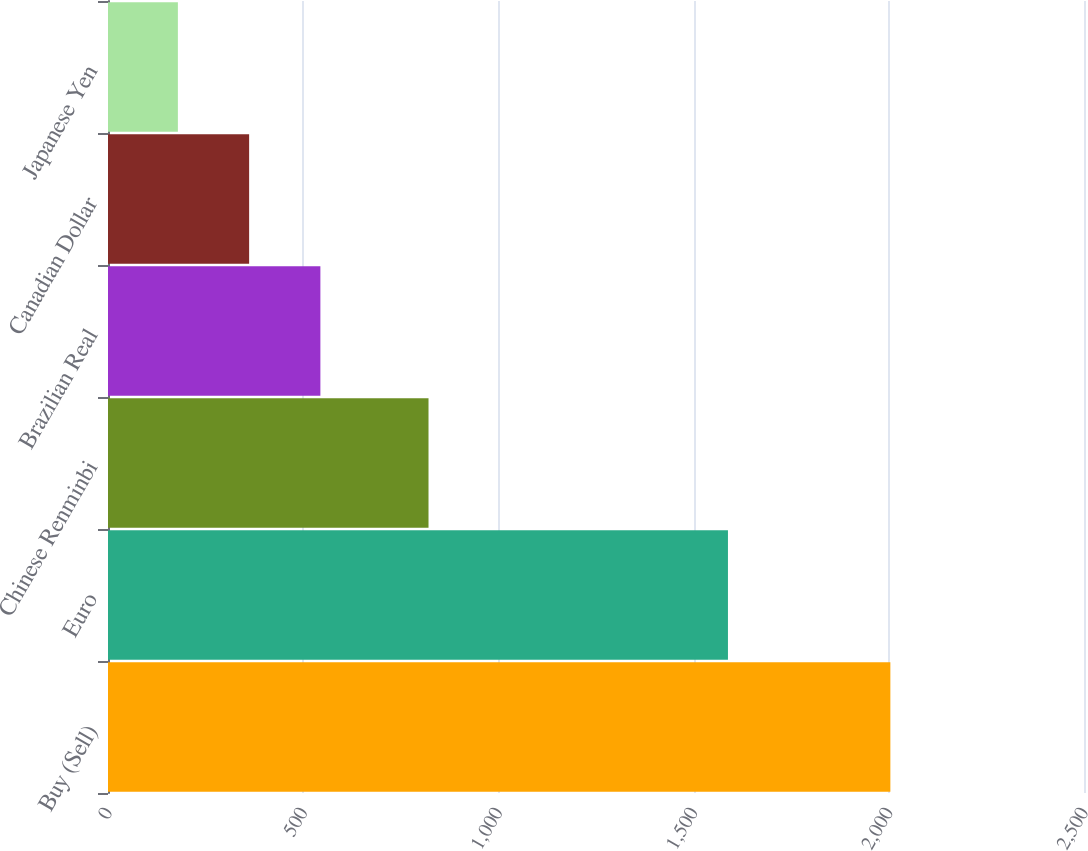Convert chart. <chart><loc_0><loc_0><loc_500><loc_500><bar_chart><fcel>Buy (Sell)<fcel>Euro<fcel>Chinese Renminbi<fcel>Brazilian Real<fcel>Canadian Dollar<fcel>Japanese Yen<nl><fcel>2004<fcel>1588<fcel>821<fcel>544<fcel>361.5<fcel>179<nl></chart> 